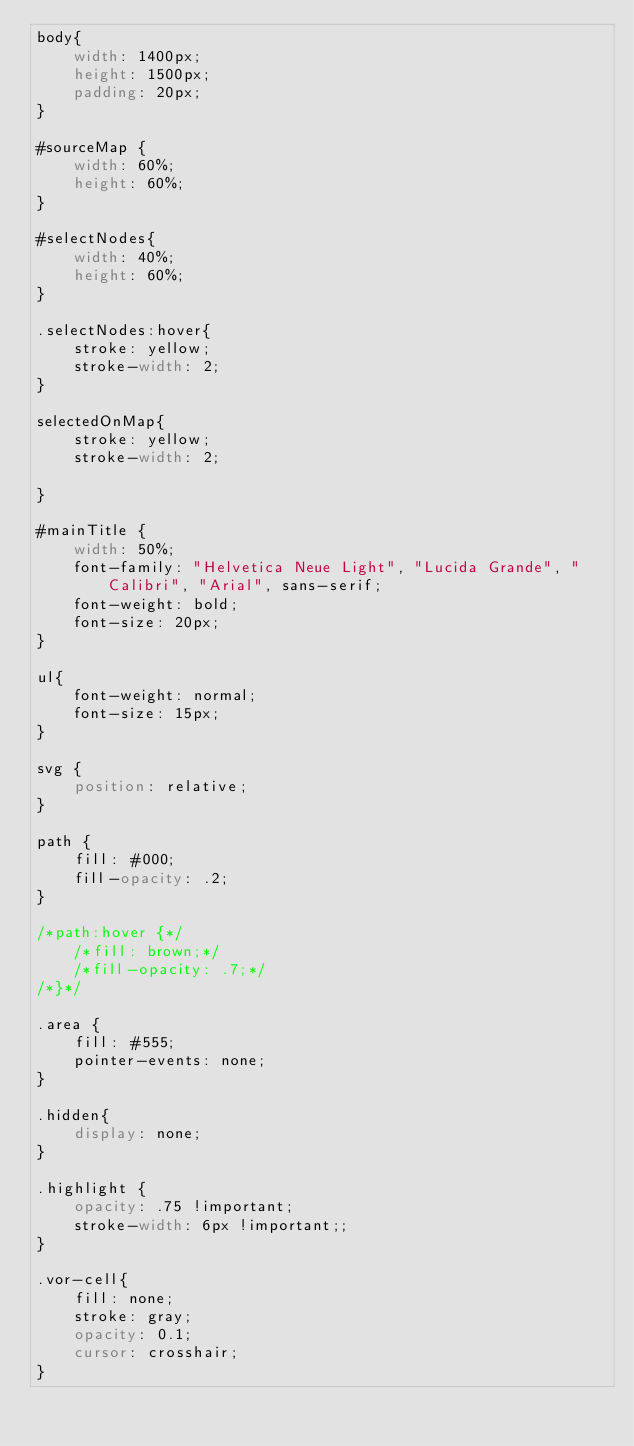<code> <loc_0><loc_0><loc_500><loc_500><_CSS_>body{
    width: 1400px;
    height: 1500px;
    padding: 20px;
}

#sourceMap {
    width: 60%;
    height: 60%;
}

#selectNodes{
    width: 40%;
    height: 60%;
}

.selectNodes:hover{
    stroke: yellow;
    stroke-width: 2;
}

selectedOnMap{
    stroke: yellow;
    stroke-width: 2;

}

#mainTitle {
    width: 50%;
    font-family: "Helvetica Neue Light", "Lucida Grande", "Calibri", "Arial", sans-serif;
    font-weight: bold;
    font-size: 20px;
}

ul{
    font-weight: normal;
    font-size: 15px;
}

svg {
    position: relative;
}

path {
    fill: #000;
    fill-opacity: .2;
}

/*path:hover {*/
    /*fill: brown;*/
    /*fill-opacity: .7;*/
/*}*/

.area {
    fill: #555;
    pointer-events: none;
}

.hidden{
    display: none;
}

.highlight {
    opacity: .75 !important;
    stroke-width: 6px !important;;
}

.vor-cell{
    fill: none;
    stroke: gray;
    opacity: 0.1;
    cursor: crosshair;
}</code> 